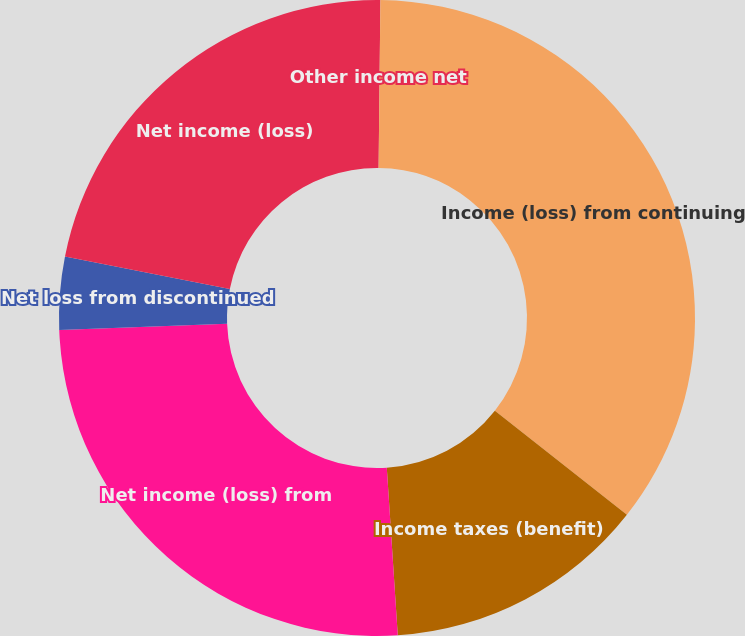Convert chart to OTSL. <chart><loc_0><loc_0><loc_500><loc_500><pie_chart><fcel>Other income net<fcel>Income (loss) from continuing<fcel>Income taxes (benefit)<fcel>Net income (loss) from<fcel>Net loss from discontinued<fcel>Net income (loss)<nl><fcel>0.17%<fcel>35.45%<fcel>13.35%<fcel>25.44%<fcel>3.7%<fcel>21.91%<nl></chart> 